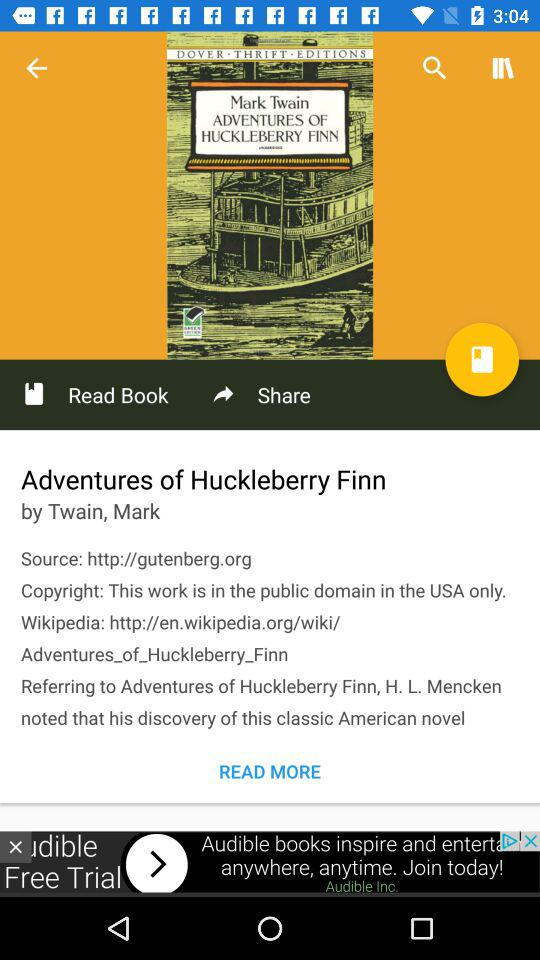What is the title of the book? The title of the book is "Adventures of Huckleberry Finn". 